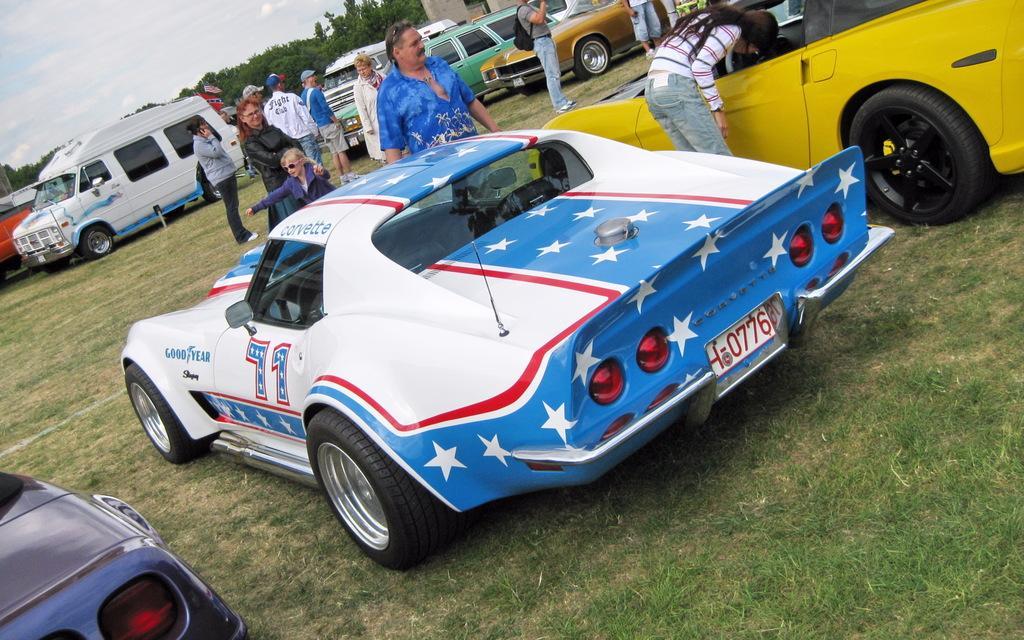Can you describe this image briefly? In this picture there is a car in the center of the image and there are cars in the background area of the image, there is grassland around the area of the image and there are people at the top side of the image. 